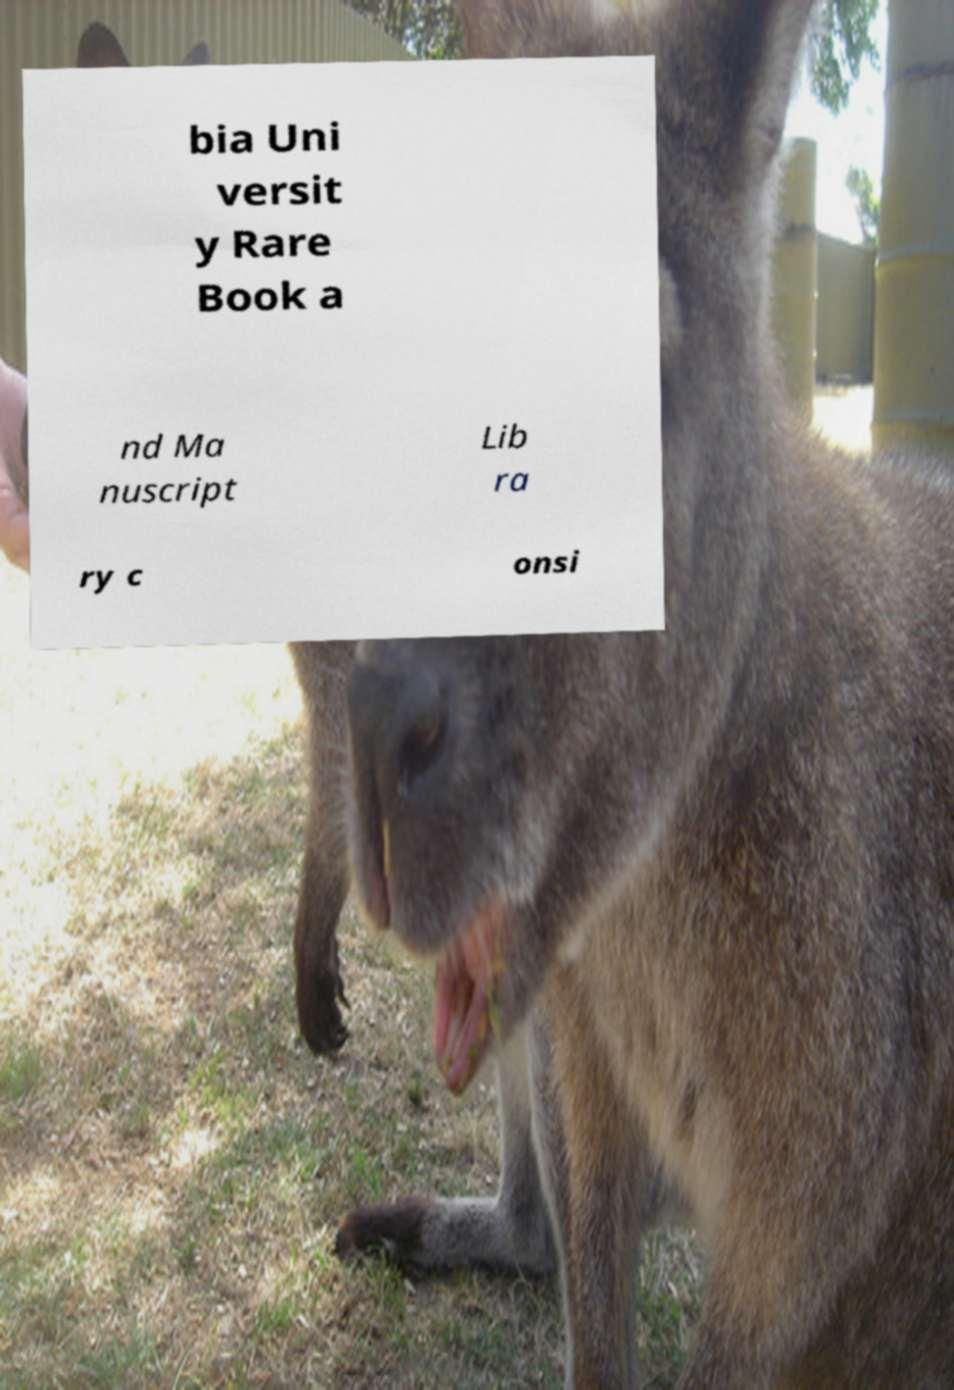Please identify and transcribe the text found in this image. bia Uni versit y Rare Book a nd Ma nuscript Lib ra ry c onsi 